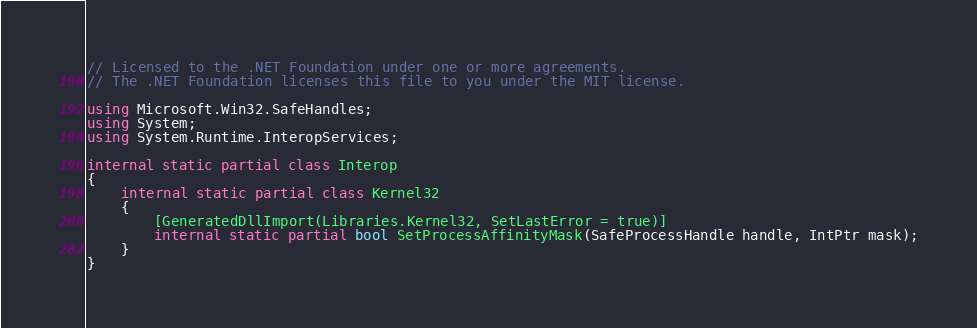Convert code to text. <code><loc_0><loc_0><loc_500><loc_500><_C#_>// Licensed to the .NET Foundation under one or more agreements.
// The .NET Foundation licenses this file to you under the MIT license.

using Microsoft.Win32.SafeHandles;
using System;
using System.Runtime.InteropServices;

internal static partial class Interop
{
    internal static partial class Kernel32
    {
        [GeneratedDllImport(Libraries.Kernel32, SetLastError = true)]
        internal static partial bool SetProcessAffinityMask(SafeProcessHandle handle, IntPtr mask);
    }
}
</code> 